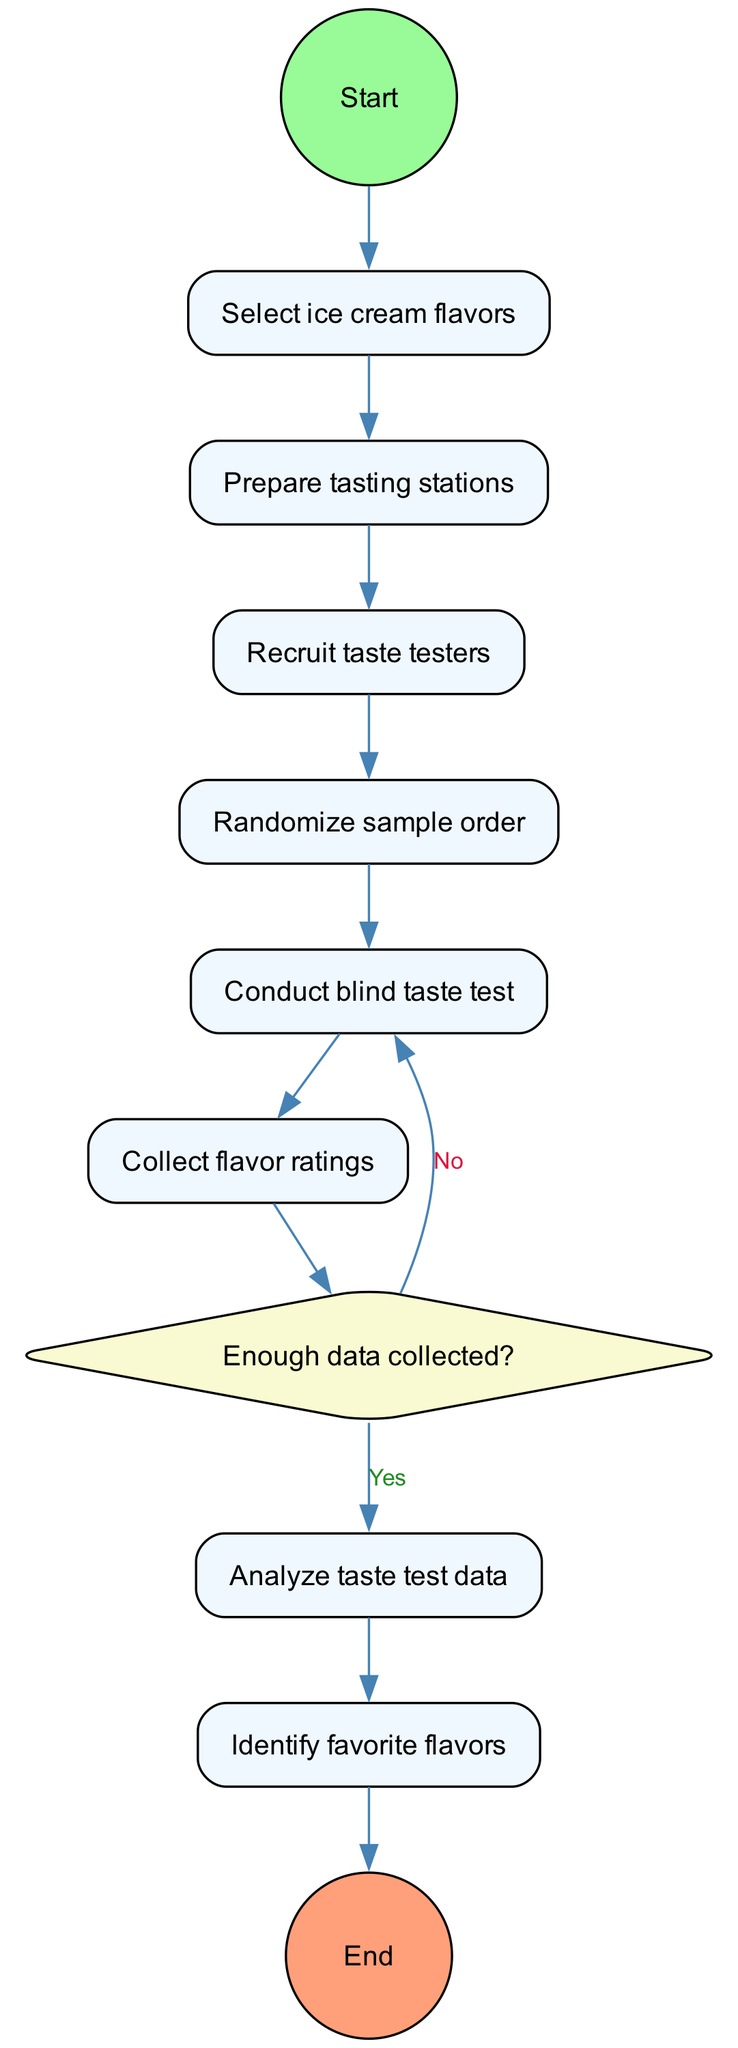What is the first activity in the diagram? The first activity node after the Start node is "Select ice cream flavors," as it is directly connected to the Start node.
Answer: Select ice cream flavors How many activities are there in total? There are eight activities listed in the diagram, including the decision node as a separate entity.
Answer: Eight What happens after "Collect flavor ratings"? The next step after "Collect flavor ratings" is the decision node asking "Enough data collected?" as illustrated by the directed edge originating from the "Collect flavor ratings" node.
Answer: Enough data collected? If the answer to the decision "Enough data collected?" is yes, what is the next step? If the answer is yes, the flow proceeds to "Analyze taste test data," following the edge directed from the decision node to this activity.
Answer: Analyze taste test data Which activity directly follows the "Recruit taste testers"? The activity that follows "Recruit taste testers" is "Randomize sample order," as indicated by the edge leading in that direction.
Answer: Randomize sample order How does the process conclude? The process concludes at the final node labeled "End," which follows the activity "Identify favorite flavors," indicating that the taste testing activity is complete.
Answer: End What shape represents decision nodes in the diagram? Decision nodes are represented by diamond shapes, which is a standard convention in activity diagrams to indicate points where decisions are made.
Answer: Diamond If the data collected is not sufficient, which step needs to be repeated? If the data collected is not sufficient, the flow returns to "Conduct blind taste test," as indicated by the edge from the decision node's no branch back to that activity.
Answer: Conduct blind taste test 